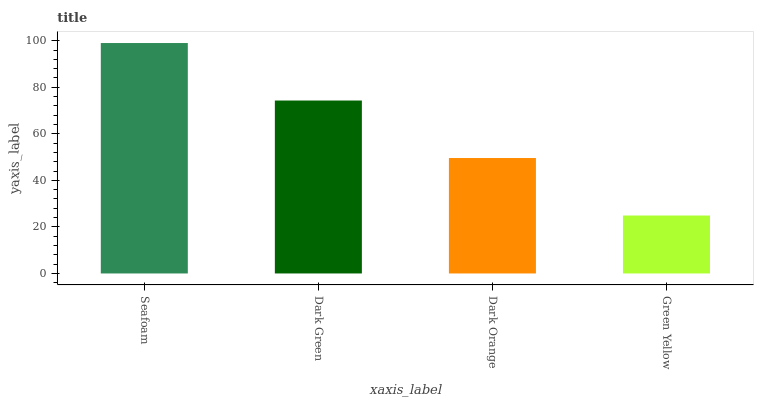Is Green Yellow the minimum?
Answer yes or no. Yes. Is Seafoam the maximum?
Answer yes or no. Yes. Is Dark Green the minimum?
Answer yes or no. No. Is Dark Green the maximum?
Answer yes or no. No. Is Seafoam greater than Dark Green?
Answer yes or no. Yes. Is Dark Green less than Seafoam?
Answer yes or no. Yes. Is Dark Green greater than Seafoam?
Answer yes or no. No. Is Seafoam less than Dark Green?
Answer yes or no. No. Is Dark Green the high median?
Answer yes or no. Yes. Is Dark Orange the low median?
Answer yes or no. Yes. Is Seafoam the high median?
Answer yes or no. No. Is Green Yellow the low median?
Answer yes or no. No. 